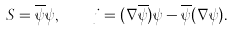<formula> <loc_0><loc_0><loc_500><loc_500>S = \overline { \psi } \psi , \quad { j } = ( \nabla \overline { \psi } ) \psi - \overline { \psi } ( \nabla \psi ) .</formula> 